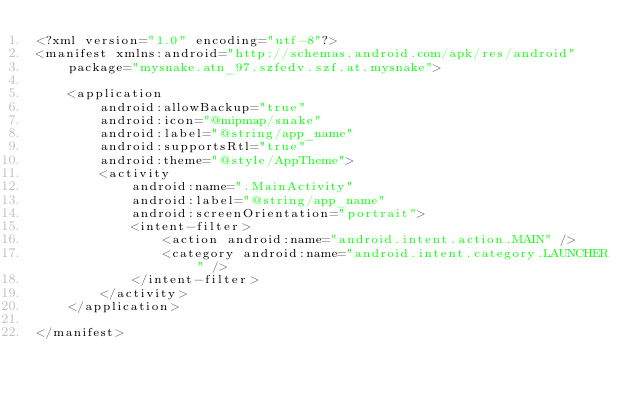<code> <loc_0><loc_0><loc_500><loc_500><_XML_><?xml version="1.0" encoding="utf-8"?>
<manifest xmlns:android="http://schemas.android.com/apk/res/android"
    package="mysnake.atn_97.szfedv.szf.at.mysnake">

    <application
        android:allowBackup="true"
        android:icon="@mipmap/snake"
        android:label="@string/app_name"
        android:supportsRtl="true"
        android:theme="@style/AppTheme">
        <activity
            android:name=".MainActivity"
            android:label="@string/app_name"
            android:screenOrientation="portrait">
            <intent-filter>
                <action android:name="android.intent.action.MAIN" />
                <category android:name="android.intent.category.LAUNCHER" />
            </intent-filter>
        </activity>
    </application>

</manifest>
</code> 